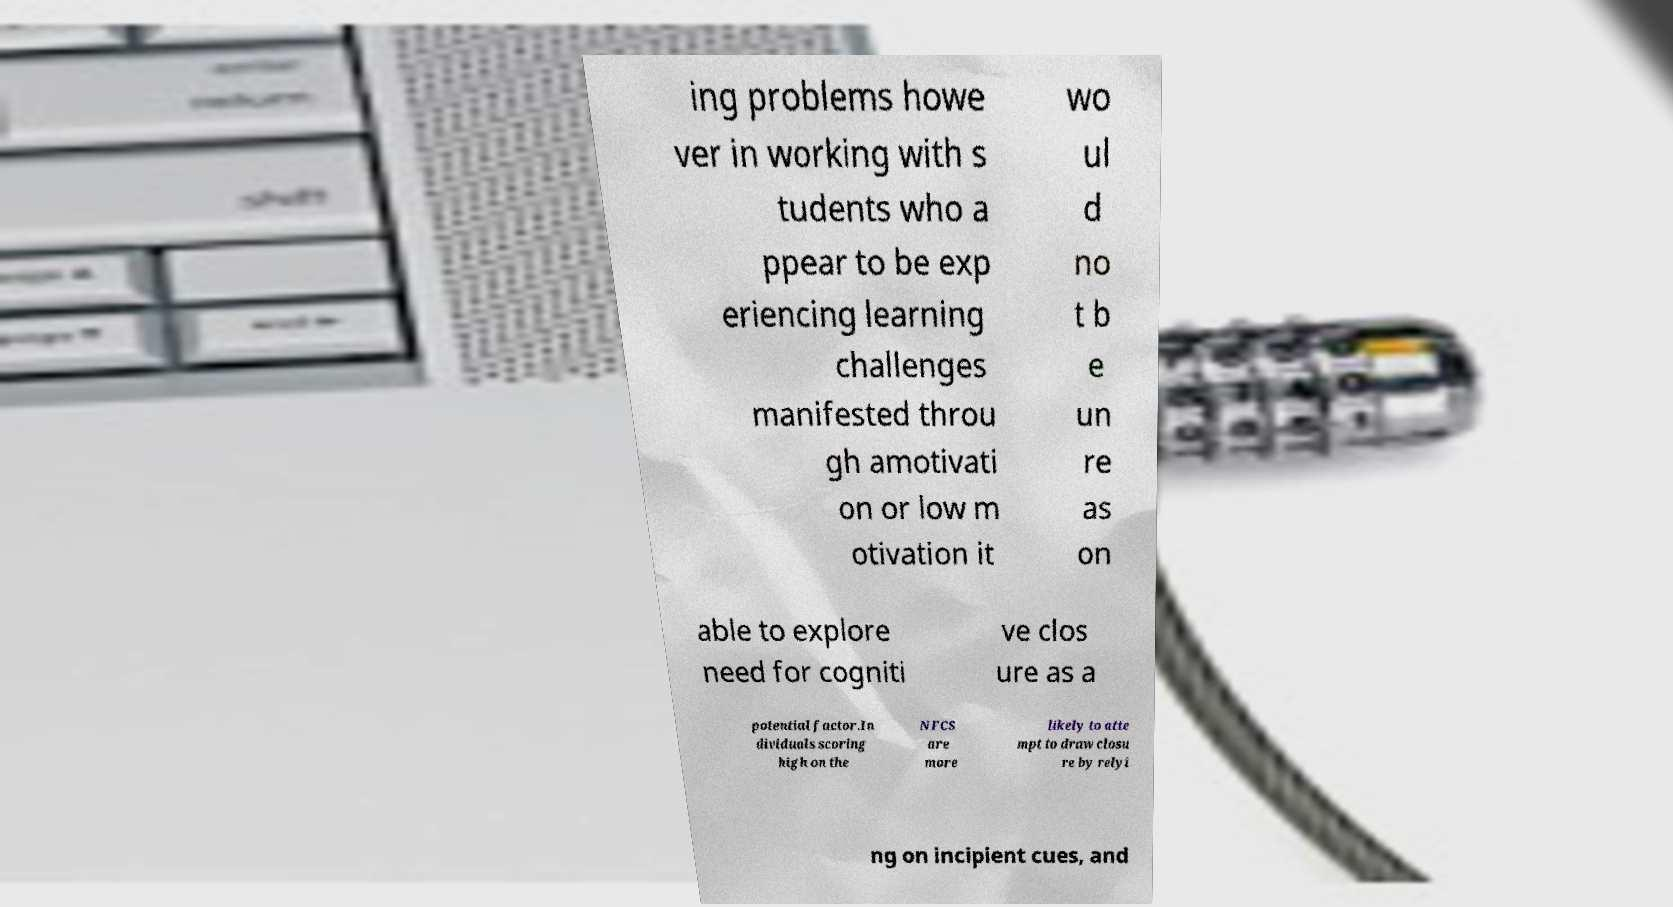Can you read and provide the text displayed in the image?This photo seems to have some interesting text. Can you extract and type it out for me? ing problems howe ver in working with s tudents who a ppear to be exp eriencing learning challenges manifested throu gh amotivati on or low m otivation it wo ul d no t b e un re as on able to explore need for cogniti ve clos ure as a potential factor.In dividuals scoring high on the NFCS are more likely to atte mpt to draw closu re by relyi ng on incipient cues, and 